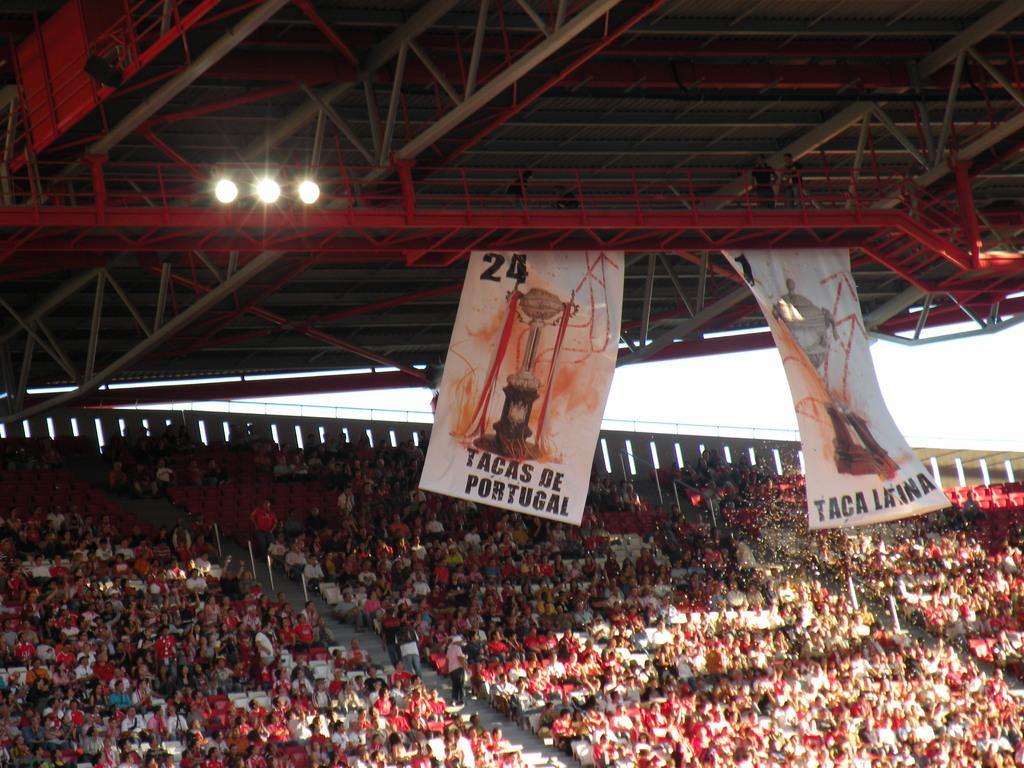Provide a one-sentence caption for the provided image. A sign that reads Tacas De Portugal hangs above a crowd. 